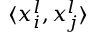<formula> <loc_0><loc_0><loc_500><loc_500>\langle x _ { i } ^ { l } , x _ { j } ^ { l } \rangle</formula> 